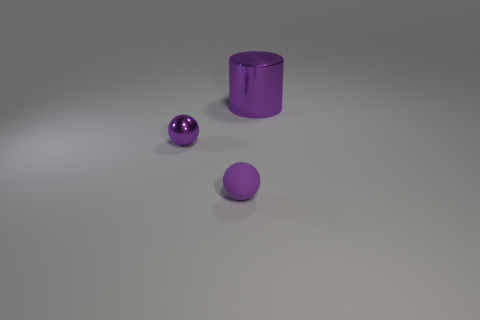Add 1 small matte things. How many objects exist? 4 Subtract 0 green spheres. How many objects are left? 3 Subtract all balls. How many objects are left? 1 Subtract all red cylinders. Subtract all yellow cubes. How many cylinders are left? 1 Subtract all red matte cylinders. Subtract all small purple balls. How many objects are left? 1 Add 1 large purple metal cylinders. How many large purple metal cylinders are left? 2 Add 3 yellow shiny things. How many yellow shiny things exist? 3 